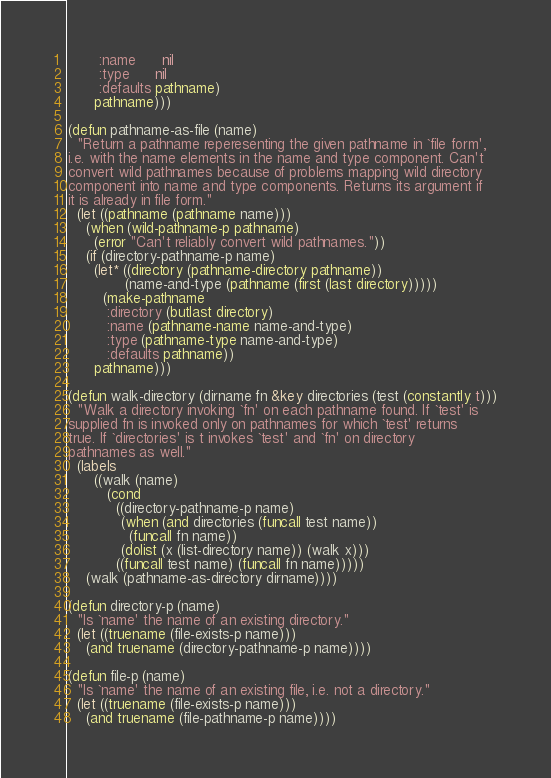<code> <loc_0><loc_0><loc_500><loc_500><_Lisp_>       :name      nil
       :type      nil
       :defaults pathname)
      pathname)))

(defun pathname-as-file (name)
  "Return a pathname reperesenting the given pathname in `file form',
i.e. with the name elements in the name and type component. Can't
convert wild pathnames because of problems mapping wild directory
component into name and type components. Returns its argument if
it is already in file form."
  (let ((pathname (pathname name)))
    (when (wild-pathname-p pathname)
      (error "Can't reliably convert wild pathnames."))
    (if (directory-pathname-p name)
      (let* ((directory (pathname-directory pathname))
             (name-and-type (pathname (first (last directory)))))
        (make-pathname 
         :directory (butlast directory)
         :name (pathname-name name-and-type)
         :type (pathname-type name-and-type)
         :defaults pathname))
      pathname)))

(defun walk-directory (dirname fn &key directories (test (constantly t)))
  "Walk a directory invoking `fn' on each pathname found. If `test' is
supplied fn is invoked only on pathnames for which `test' returns
true. If `directories' is t invokes `test' and `fn' on directory
pathnames as well."
  (labels
      ((walk (name)
         (cond
           ((directory-pathname-p name)
            (when (and directories (funcall test name))
              (funcall fn name))
            (dolist (x (list-directory name)) (walk x)))
           ((funcall test name) (funcall fn name)))))
    (walk (pathname-as-directory dirname))))

(defun directory-p (name)
  "Is `name' the name of an existing directory."
  (let ((truename (file-exists-p name)))
    (and truename (directory-pathname-p name))))

(defun file-p (name)
  "Is `name' the name of an existing file, i.e. not a directory."
  (let ((truename (file-exists-p name)))
    (and truename (file-pathname-p name))))


</code> 